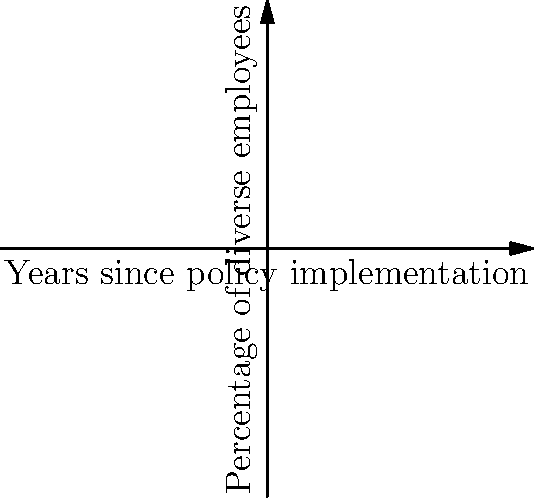The graph shows the percentage of diverse employees in a factory over the years since implementing a diversity policy. What is the average rate of increase in the percentage of diverse employees per year between points A and E? To find the average rate of increase per year between points A and E, we need to:

1. Calculate the total increase in percentage:
   Point E (year 4): 45%
   Point A (year 0): 20%
   Total increase = 45% - 20% = 25%

2. Calculate the time span:
   Time span = 4 years - 0 years = 4 years

3. Calculate the average rate of increase per year:
   Average rate = Total increase ÷ Time span
   $$ \text{Average rate} = \frac{25\%}{4 \text{ years}} = 6.25\% \text{ per year} $$

Therefore, the average rate of increase in the percentage of diverse employees per year between points A and E is 6.25% per year.
Answer: 6.25% per year 